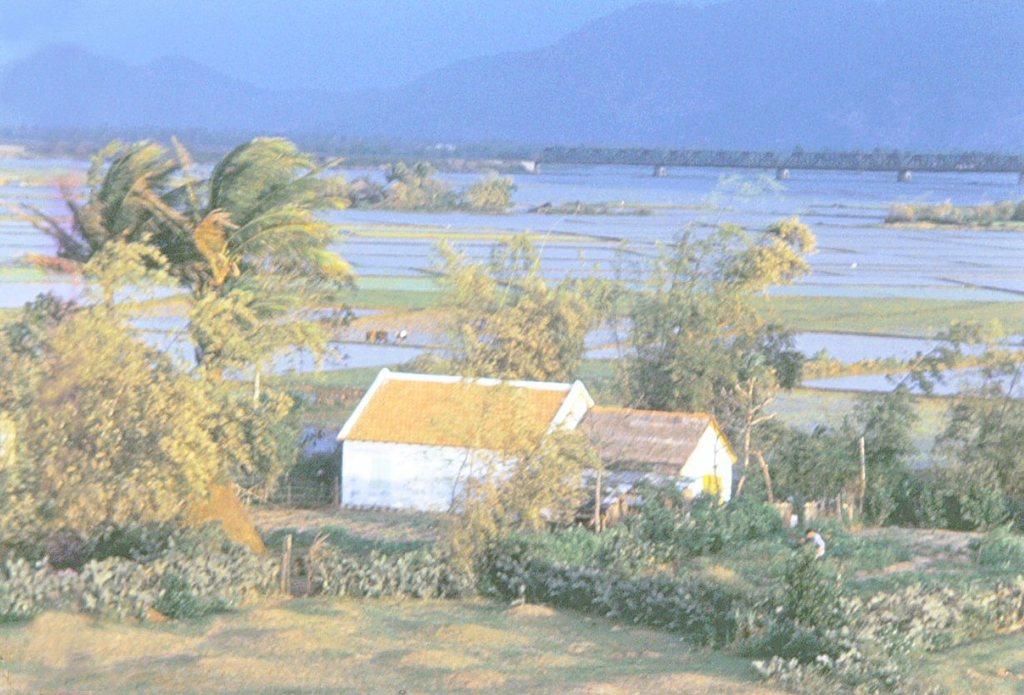How would you summarize this image in a sentence or two? In front of the image there are plants, trees. There are houses. There is a person sitting. In the center of the image there is water. There is a bridge. In the background of the image there are mountains and sky. 